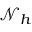<formula> <loc_0><loc_0><loc_500><loc_500>\mathcal { N } _ { h }</formula> 